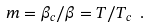Convert formula to latex. <formula><loc_0><loc_0><loc_500><loc_500>m = \beta _ { c } / \beta = T / T _ { c } \ .</formula> 